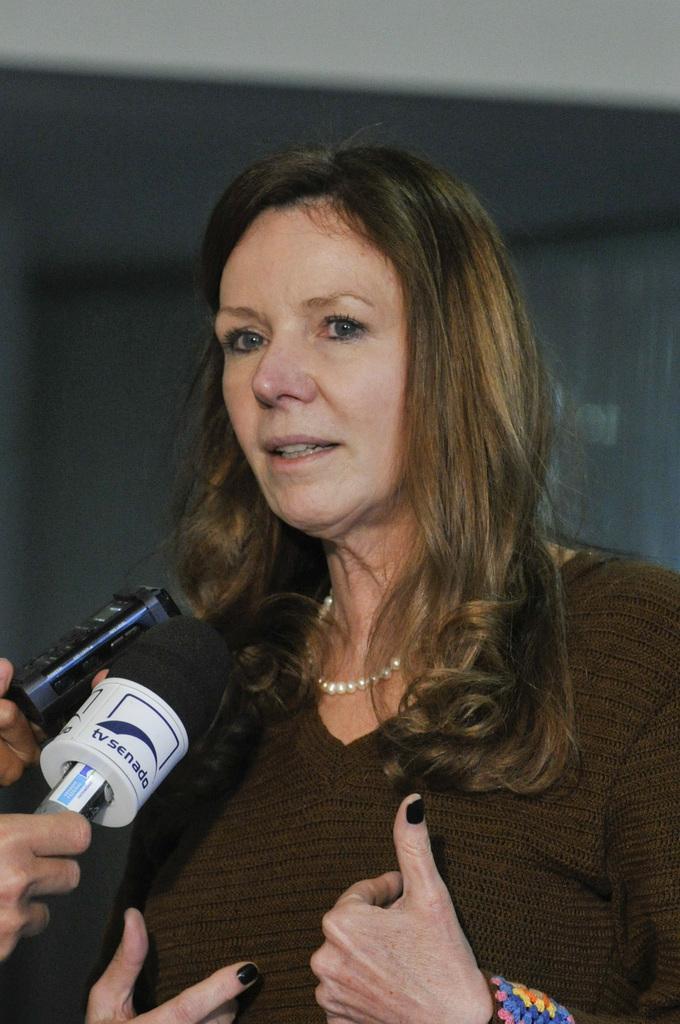Describe this image in one or two sentences. In the foreground I can see a woman and mike's. In the background I can see a wall. This image is taken may be in a hall. 